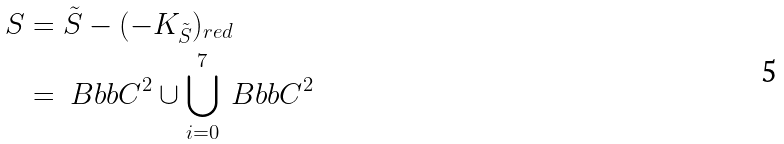<formula> <loc_0><loc_0><loc_500><loc_500>S & = { \tilde { S } } - ( - { K _ { \tilde { S } } } ) _ { r e d } \\ & = { \ B b b C } ^ { 2 } \cup \bigcup _ { i = 0 } ^ { 7 } { \ B b b C } ^ { 2 }</formula> 